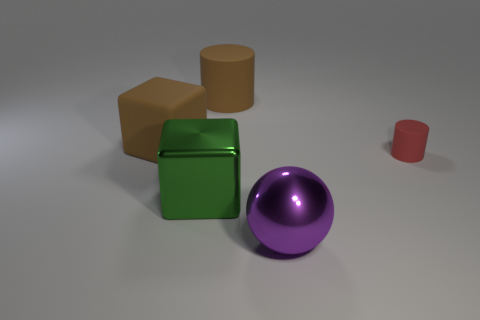What number of other objects are there of the same material as the tiny cylinder?
Ensure brevity in your answer.  2. How many objects are either matte cylinders that are to the left of the purple object or brown things in front of the large matte cylinder?
Ensure brevity in your answer.  2. Is the shape of the big metal object that is on the right side of the brown cylinder the same as the large rubber object that is left of the metal block?
Your response must be concise. No. What is the shape of the purple object that is the same size as the green cube?
Give a very brief answer. Sphere. What number of metal things are either tiny cyan spheres or large blocks?
Keep it short and to the point. 1. Is the material of the block behind the red object the same as the large brown object on the right side of the large green metal object?
Give a very brief answer. Yes. There is another thing that is the same material as the big green object; what color is it?
Offer a terse response. Purple. Are there more cylinders that are in front of the green block than things on the left side of the small matte cylinder?
Offer a very short reply. No. Are any big brown blocks visible?
Your response must be concise. Yes. There is a big object that is the same color as the big rubber cube; what is its material?
Keep it short and to the point. Rubber. 